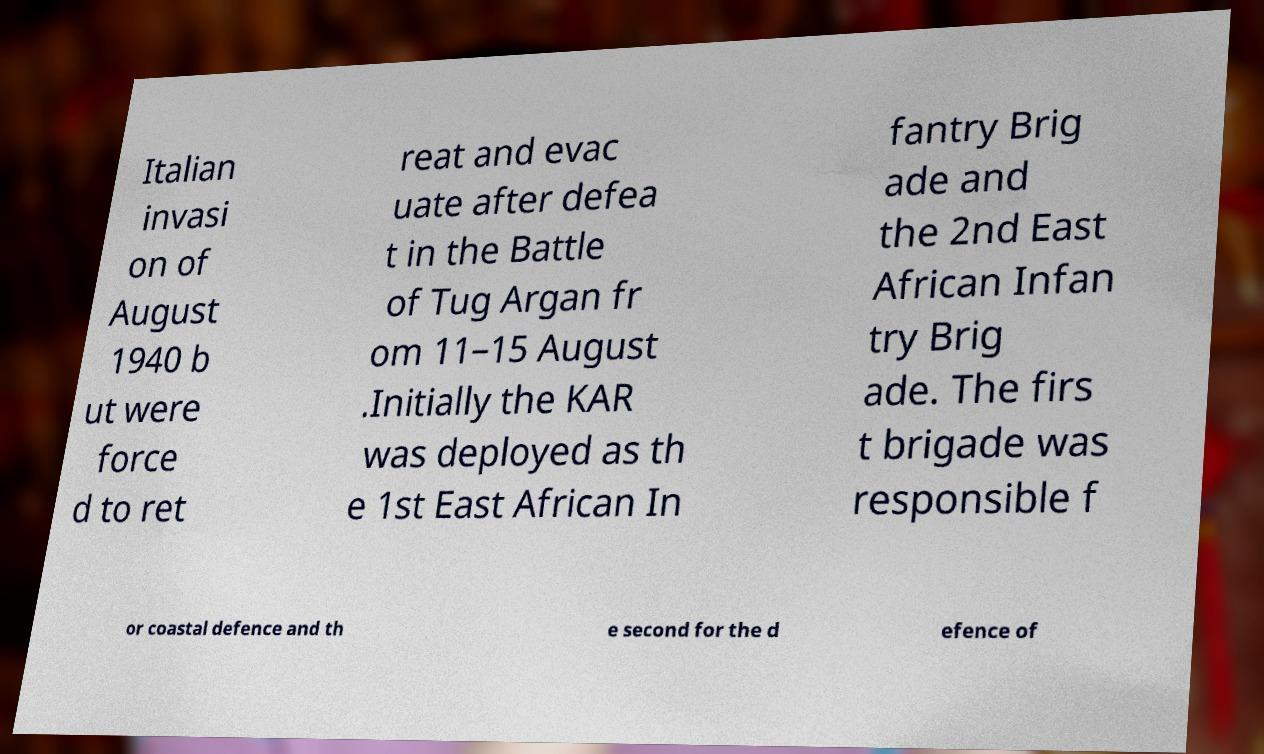Could you assist in decoding the text presented in this image and type it out clearly? Italian invasi on of August 1940 b ut were force d to ret reat and evac uate after defea t in the Battle of Tug Argan fr om 11–15 August .Initially the KAR was deployed as th e 1st East African In fantry Brig ade and the 2nd East African Infan try Brig ade. The firs t brigade was responsible f or coastal defence and th e second for the d efence of 